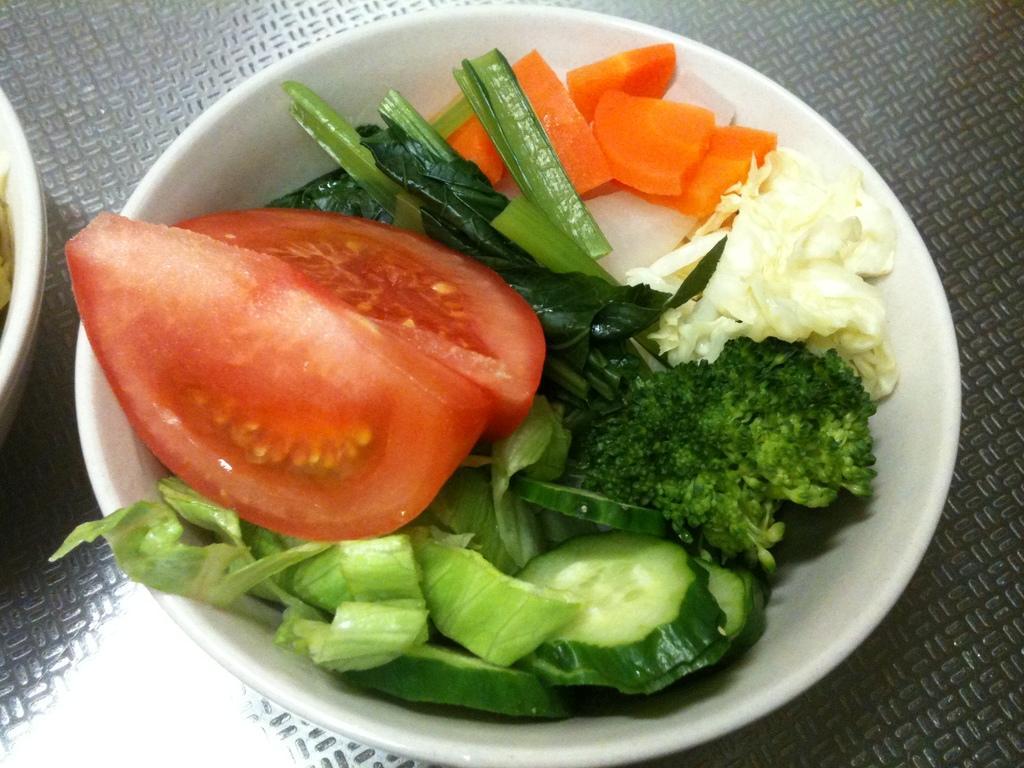Describe this image in one or two sentences. In this picture we can see a few vegetables in a bowl. There is another bowl on the left side. 